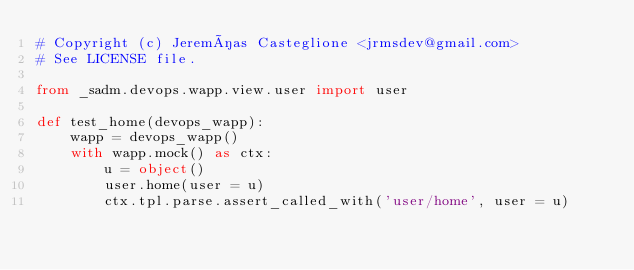<code> <loc_0><loc_0><loc_500><loc_500><_Python_># Copyright (c) Jeremías Casteglione <jrmsdev@gmail.com>
# See LICENSE file.

from _sadm.devops.wapp.view.user import user

def test_home(devops_wapp):
	wapp = devops_wapp()
	with wapp.mock() as ctx:
		u = object()
		user.home(user = u)
		ctx.tpl.parse.assert_called_with('user/home', user = u)
</code> 